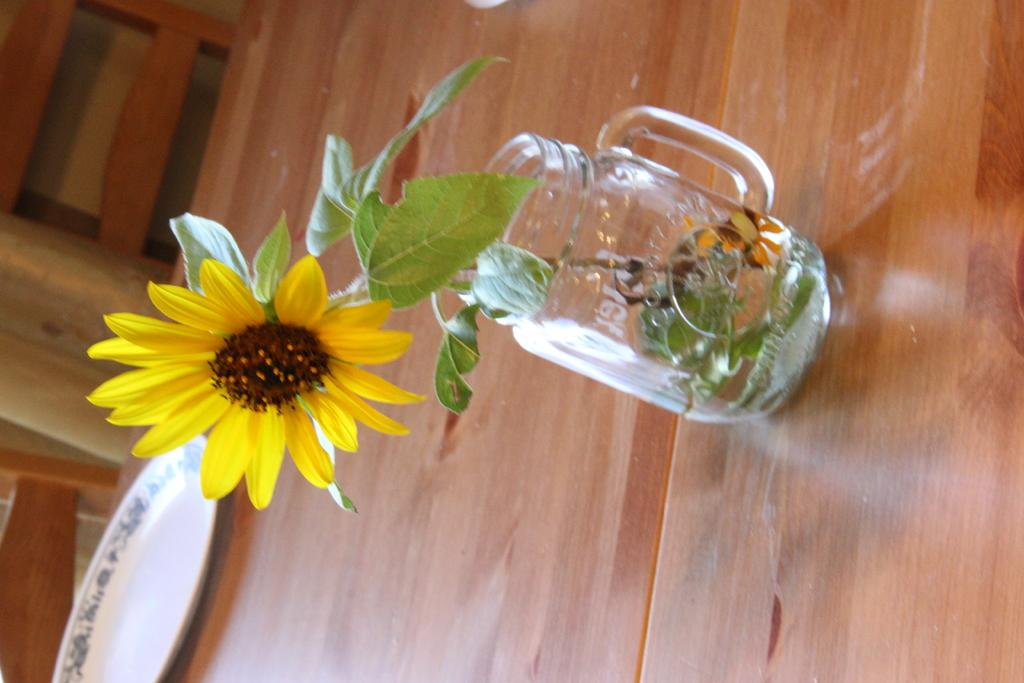How is the image oriented? The image is rotated. What is inside the jar in the image? There is a sunflower in a jar. What other parts of the sunflower can be seen in the image? The sunflower has leaves. What is on the table in the image? There is a plate on a wooden table. What type of seating is in front of the table? There are two chairs in front of the table. What type of fruit is hanging from the sunflower in the image? There is no fruit hanging from the sunflower in the image; it is a sunflower plant with leaves. 